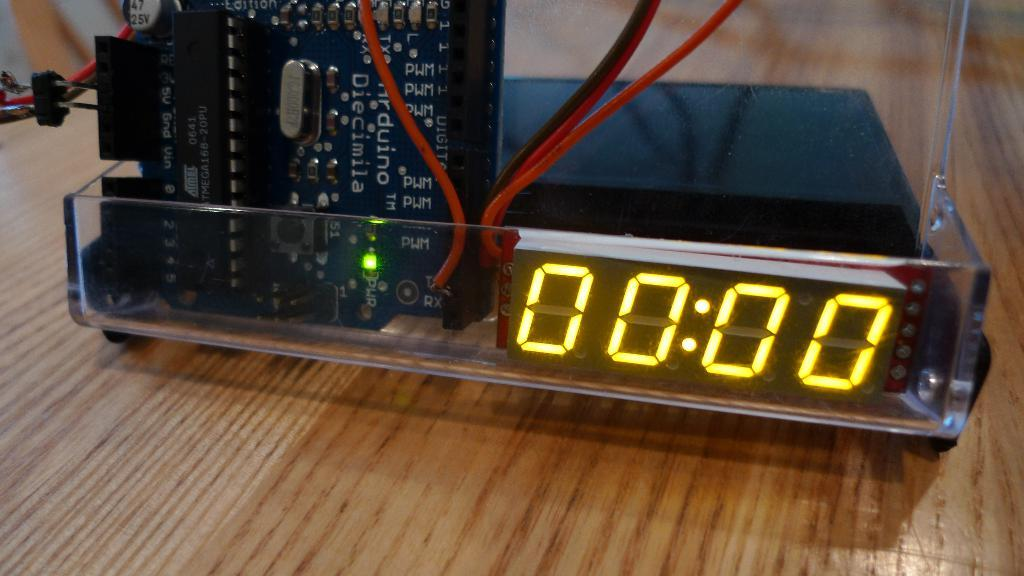What is the main object on the wooden surface in the image? There is a glass tray on a wooden surface in the image. What items can be found inside the glass tray? There are digital display boards, a circuit board, and a box in the tray. How are the digital display boards and circuit board connected? There are cables connected to the circuit board in the tray. What type of polish is being applied to the support in the image? There is no support or polish present in the image; it features a glass tray with digital display boards, a circuit board, and a box. 